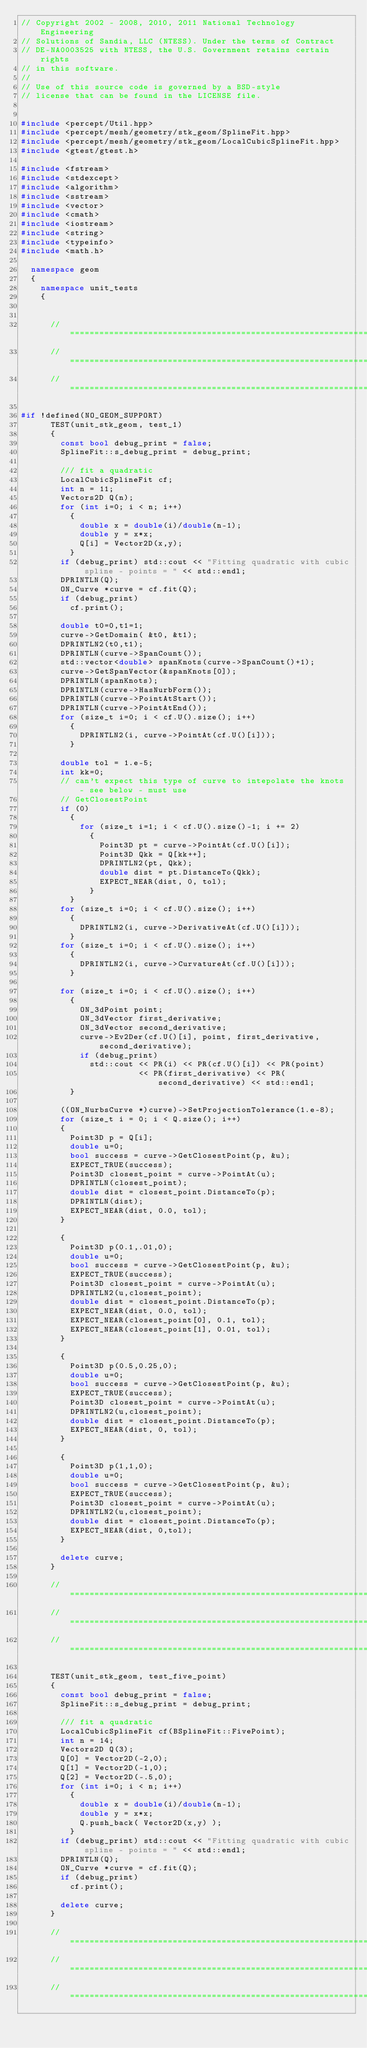<code> <loc_0><loc_0><loc_500><loc_500><_C++_>// Copyright 2002 - 2008, 2010, 2011 National Technology Engineering
// Solutions of Sandia, LLC (NTESS). Under the terms of Contract
// DE-NA0003525 with NTESS, the U.S. Government retains certain rights
// in this software.
//
// Use of this source code is governed by a BSD-style
// license that can be found in the LICENSE file.


#include <percept/Util.hpp>
#include <percept/mesh/geometry/stk_geom/SplineFit.hpp>
#include <percept/mesh/geometry/stk_geom/LocalCubicSplineFit.hpp>
#include <gtest/gtest.h>

#include <fstream>
#include <stdexcept>
#include <algorithm>
#include <sstream>
#include <vector>
#include <cmath>
#include <iostream>
#include <string>
#include <typeinfo>
#include <math.h>

  namespace geom
  {
    namespace unit_tests
    {


      //=============================================================================
      //=============================================================================
      //=============================================================================

#if !defined(NO_GEOM_SUPPORT)
      TEST(unit_stk_geom, test_1)
      {
        const bool debug_print = false;
        SplineFit::s_debug_print = debug_print;

        /// fit a quadratic
        LocalCubicSplineFit cf;
        int n = 11;
        Vectors2D Q(n);
        for (int i=0; i < n; i++)
          {
            double x = double(i)/double(n-1);
            double y = x*x;
            Q[i] = Vector2D(x,y);
          }
        if (debug_print) std::cout << "Fitting quadratic with cubic spline - points = " << std::endl;
        DPRINTLN(Q);
        ON_Curve *curve = cf.fit(Q);
        if (debug_print)
          cf.print();

        double t0=0,t1=1;
        curve->GetDomain( &t0, &t1);
        DPRINTLN2(t0,t1);
        DPRINTLN(curve->SpanCount());
        std::vector<double> spanKnots(curve->SpanCount()+1);
        curve->GetSpanVector(&spanKnots[0]);
        DPRINTLN(spanKnots);
        DPRINTLN(curve->HasNurbForm());
        DPRINTLN(curve->PointAtStart());
        DPRINTLN(curve->PointAtEnd());
        for (size_t i=0; i < cf.U().size(); i++)
          {
            DPRINTLN2(i, curve->PointAt(cf.U()[i]));
          }

        double tol = 1.e-5;
        int kk=0;
        // can't expect this type of curve to intepolate the knots - see below - must use
        // GetClosestPoint
        if (0)
          {
            for (size_t i=1; i < cf.U().size()-1; i += 2)
              {
                Point3D pt = curve->PointAt(cf.U()[i]);
                Point3D Qkk = Q[kk++];
                DPRINTLN2(pt, Qkk);
                double dist = pt.DistanceTo(Qkk);
                EXPECT_NEAR(dist, 0, tol);
              }
          }
        for (size_t i=0; i < cf.U().size(); i++)
          {
            DPRINTLN2(i, curve->DerivativeAt(cf.U()[i]));
          }
        for (size_t i=0; i < cf.U().size(); i++)
          {
            DPRINTLN2(i, curve->CurvatureAt(cf.U()[i]));
          }

        for (size_t i=0; i < cf.U().size(); i++)
          {
            ON_3dPoint point;
            ON_3dVector first_derivative;
            ON_3dVector second_derivative;
            curve->Ev2Der(cf.U()[i], point, first_derivative, second_derivative);
            if (debug_print)
              std::cout << PR(i) << PR(cf.U()[i]) << PR(point)
                        << PR(first_derivative) << PR(second_derivative) << std::endl;
          }

        ((ON_NurbsCurve *)curve)->SetProjectionTolerance(1.e-8);
        for (size_t i = 0; i < Q.size(); i++)
        {
          Point3D p = Q[i];
          double u=0;
          bool success = curve->GetClosestPoint(p, &u);
          EXPECT_TRUE(success);
          Point3D closest_point = curve->PointAt(u);
          DPRINTLN(closest_point);
          double dist = closest_point.DistanceTo(p);
          DPRINTLN(dist);
          EXPECT_NEAR(dist, 0.0, tol);
        }

        {
          Point3D p(0.1,.01,0);
          double u=0;
          bool success = curve->GetClosestPoint(p, &u);
          EXPECT_TRUE(success);
          Point3D closest_point = curve->PointAt(u);
          DPRINTLN2(u,closest_point);
          double dist = closest_point.DistanceTo(p);
          EXPECT_NEAR(dist, 0.0, tol);
          EXPECT_NEAR(closest_point[0], 0.1, tol);
          EXPECT_NEAR(closest_point[1], 0.01, tol);
        }

        {
          Point3D p(0.5,0.25,0);
          double u=0;
          bool success = curve->GetClosestPoint(p, &u);
          EXPECT_TRUE(success);
          Point3D closest_point = curve->PointAt(u);
          DPRINTLN2(u,closest_point);
          double dist = closest_point.DistanceTo(p);
          EXPECT_NEAR(dist, 0, tol);
        }

        {
          Point3D p(1,1,0);
          double u=0;
          bool success = curve->GetClosestPoint(p, &u);
          EXPECT_TRUE(success);
          Point3D closest_point = curve->PointAt(u);
          DPRINTLN2(u,closest_point);
          double dist = closest_point.DistanceTo(p);
          EXPECT_NEAR(dist, 0,tol);
        }

        delete curve;
      }

      //=============================================================================
      //=============================================================================
      //=============================================================================

      TEST(unit_stk_geom, test_five_point)
      {
        const bool debug_print = false;
        SplineFit::s_debug_print = debug_print;

        /// fit a quadratic
        LocalCubicSplineFit cf(BSplineFit::FivePoint);
        int n = 14;
        Vectors2D Q(3);
        Q[0] = Vector2D(-2,0);
        Q[1] = Vector2D(-1,0);
        Q[2] = Vector2D(-.5,0);
        for (int i=0; i < n; i++)
          {
            double x = double(i)/double(n-1);
            double y = x*x;
            Q.push_back( Vector2D(x,y) );
          }
        if (debug_print) std::cout << "Fitting quadratic with cubic spline - points = " << std::endl;
        DPRINTLN(Q);
        ON_Curve *curve = cf.fit(Q);
        if (debug_print)
          cf.print();

        delete curve;
      }

      //=============================================================================
      //=============================================================================
      //=============================================================================
</code> 